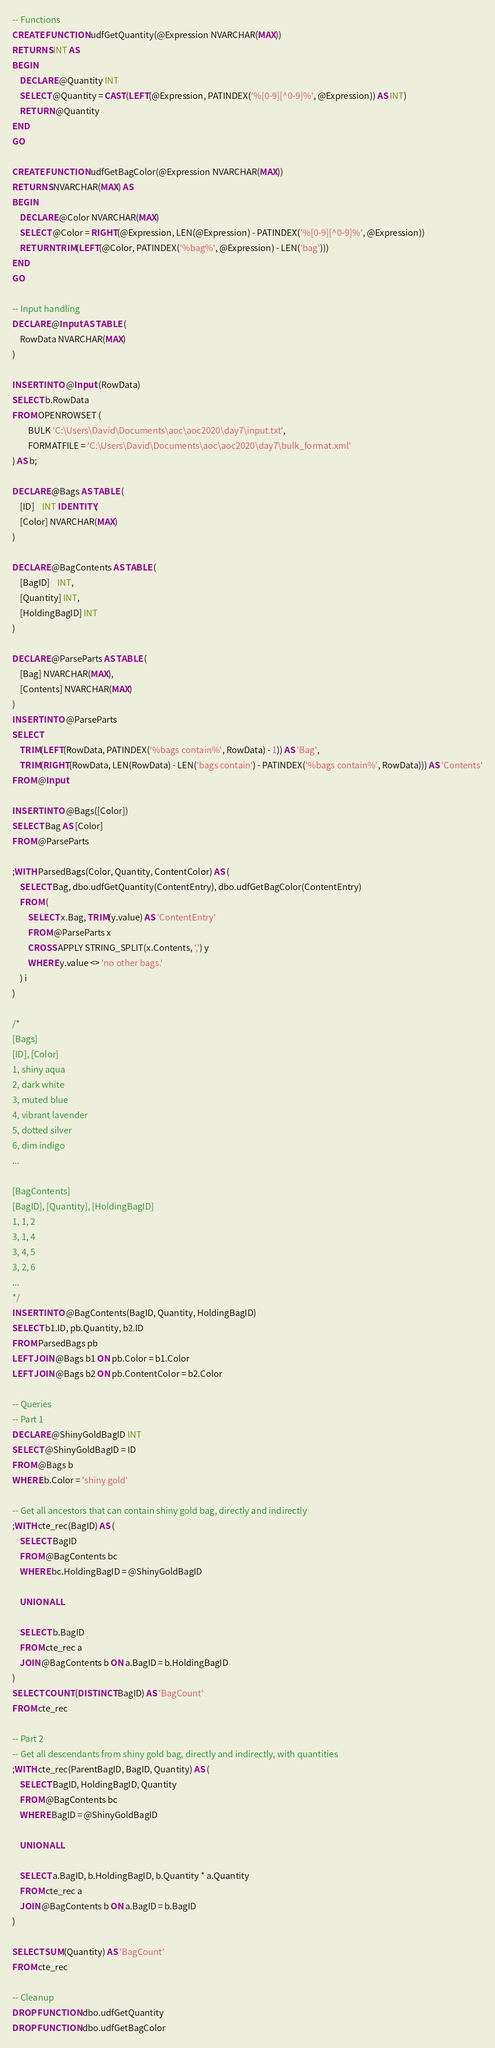Convert code to text. <code><loc_0><loc_0><loc_500><loc_500><_SQL_>-- Functions
CREATE FUNCTION udfGetQuantity(@Expression NVARCHAR(MAX))
RETURNS INT AS 
BEGIN 
	DECLARE @Quantity INT
	SELECT @Quantity = CAST(LEFT(@Expression, PATINDEX('%[0-9][^0-9]%', @Expression)) AS INT)
	RETURN @Quantity
END
GO

CREATE FUNCTION udfGetBagColor(@Expression NVARCHAR(MAX))
RETURNS NVARCHAR(MAX) AS 
BEGIN 
	DECLARE @Color NVARCHAR(MAX)
	SELECT @Color = RIGHT(@Expression, LEN(@Expression) - PATINDEX('%[0-9][^0-9]%', @Expression))
	RETURN TRIM(LEFT(@Color, PATINDEX('%bag%', @Expression) - LEN('bag')))
END
GO

-- Input handling
DECLARE @Input AS TABLE (
	RowData NVARCHAR(MAX)
)

INSERT INTO @Input (RowData)
SELECT b.RowData
FROM OPENROWSET (
		BULK 'C:\Users\David\Documents\aoc\aoc2020\day7\input.txt',
		FORMATFILE = 'C:\Users\David\Documents\aoc\aoc2020\day7\bulk_format.xml'  
) AS b;

DECLARE @Bags AS TABLE (
	[ID]	INT IDENTITY,
	[Color] NVARCHAR(MAX)
)

DECLARE @BagContents AS TABLE (
	[BagID]	INT,
	[Quantity] INT,
	[HoldingBagID] INT
)

DECLARE @ParseParts AS TABLE (
	[Bag] NVARCHAR(MAX),
	[Contents] NVARCHAR(MAX)
)
INSERT INTO @ParseParts
SELECT 
	TRIM(LEFT(RowData, PATINDEX('%bags contain%', RowData) - 1)) AS 'Bag', 
	TRIM(RIGHT(RowData, LEN(RowData) - LEN('bags contain') - PATINDEX('%bags contain%', RowData))) AS 'Contents'
FROM @Input

INSERT INTO @Bags([Color])
SELECT Bag AS [Color]
FROM @ParseParts

;WITH ParsedBags(Color, Quantity, ContentColor) AS (
	SELECT Bag, dbo.udfGetQuantity(ContentEntry), dbo.udfGetBagColor(ContentEntry)
	FROM (
		SELECT x.Bag, TRIM(y.value) AS 'ContentEntry'
		FROM @ParseParts x
		CROSS APPLY STRING_SPLIT(x.Contents, ',') y
		WHERE y.value <> 'no other bags.'
	) i
)

/*
[Bags]
[ID], [Color]
1, shiny aqua
2, dark white
3, muted blue
4, vibrant lavender
5, dotted silver
6, dim indigo
...

[BagContents]
[BagID], [Quantity], [HoldingBagID]
1, 1, 2
3, 1, 4
3, 4, 5
3, 2, 6
...
*/
INSERT INTO @BagContents(BagID, Quantity, HoldingBagID)
SELECT b1.ID, pb.Quantity, b2.ID
FROM ParsedBags pb
LEFT JOIN @Bags b1 ON pb.Color = b1.Color
LEFT JOIN @Bags b2 ON pb.ContentColor = b2.Color

-- Queries
-- Part 1
DECLARE @ShinyGoldBagID INT
SELECT @ShinyGoldBagID = ID
FROM @Bags b
WHERE b.Color = 'shiny gold'

-- Get all ancestors that can contain shiny gold bag, directly and indirectly
;WITH cte_rec(BagID) AS (
	SELECT BagID
	FROM @BagContents bc
	WHERE bc.HoldingBagID = @ShinyGoldBagID

	UNION ALL

	SELECT b.BagID
	FROM cte_rec a
	JOIN @BagContents b ON a.BagID = b.HoldingBagID
)
SELECT COUNT(DISTINCT BagID) AS 'BagCount'
FROM cte_rec

-- Part 2
-- Get all descendants from shiny gold bag, directly and indirectly, with quantities
;WITH cte_rec(ParentBagID, BagID, Quantity) AS (
	SELECT BagID, HoldingBagID, Quantity
	FROM @BagContents bc
	WHERE BagID = @ShinyGoldBagID

	UNION ALL

	SELECT a.BagID, b.HoldingBagID, b.Quantity * a.Quantity
	FROM cte_rec a
	JOIN @BagContents b ON a.BagID = b.BagID
)

SELECT SUM(Quantity) AS 'BagCount'
FROM cte_rec

-- Cleanup
DROP FUNCTION dbo.udfGetQuantity
DROP FUNCTION dbo.udfGetBagColor</code> 